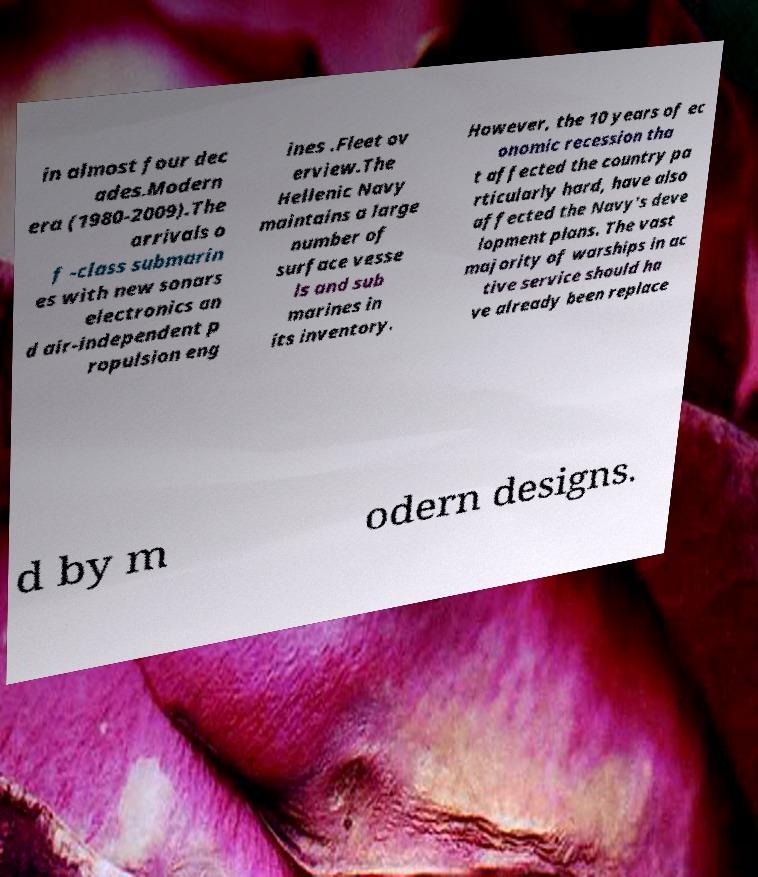What messages or text are displayed in this image? I need them in a readable, typed format. in almost four dec ades.Modern era (1980-2009).The arrivals o f -class submarin es with new sonars electronics an d air-independent p ropulsion eng ines .Fleet ov erview.The Hellenic Navy maintains a large number of surface vesse ls and sub marines in its inventory. However, the 10 years of ec onomic recession tha t affected the country pa rticularly hard, have also affected the Navy's deve lopment plans. The vast majority of warships in ac tive service should ha ve already been replace d by m odern designs. 